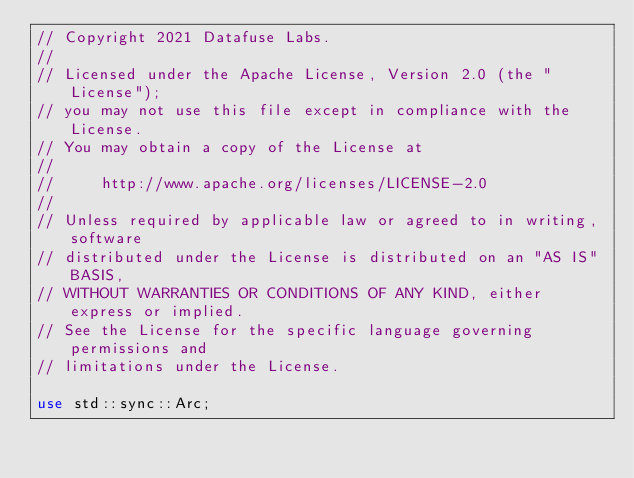<code> <loc_0><loc_0><loc_500><loc_500><_Rust_>// Copyright 2021 Datafuse Labs.
//
// Licensed under the Apache License, Version 2.0 (the "License");
// you may not use this file except in compliance with the License.
// You may obtain a copy of the License at
//
//     http://www.apache.org/licenses/LICENSE-2.0
//
// Unless required by applicable law or agreed to in writing, software
// distributed under the License is distributed on an "AS IS" BASIS,
// WITHOUT WARRANTIES OR CONDITIONS OF ANY KIND, either express or implied.
// See the License for the specific language governing permissions and
// limitations under the License.

use std::sync::Arc;
</code> 